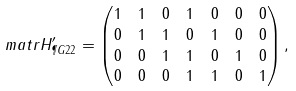Convert formula to latex. <formula><loc_0><loc_0><loc_500><loc_500>\ m a t r { H } ^ { \prime } _ { \P G { 2 } { 2 } } & = \begin{pmatrix} 1 & 1 & 0 & 1 & 0 & 0 & 0 \\ 0 & 1 & 1 & 0 & 1 & 0 & 0 \\ 0 & 0 & 1 & 1 & 0 & 1 & 0 \\ 0 & 0 & 0 & 1 & 1 & 0 & 1 \end{pmatrix} ,</formula> 